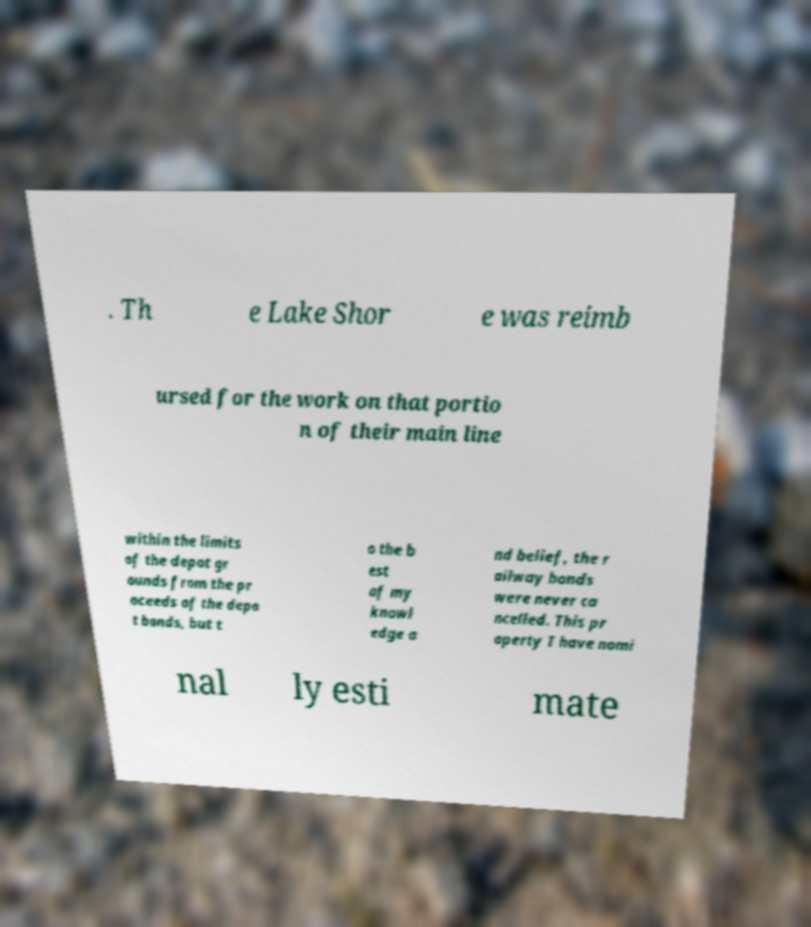Please identify and transcribe the text found in this image. . Th e Lake Shor e was reimb ursed for the work on that portio n of their main line within the limits of the depot gr ounds from the pr oceeds of the depo t bonds, but t o the b est of my knowl edge a nd belief, the r ailway bonds were never ca ncelled. This pr operty I have nomi nal ly esti mate 